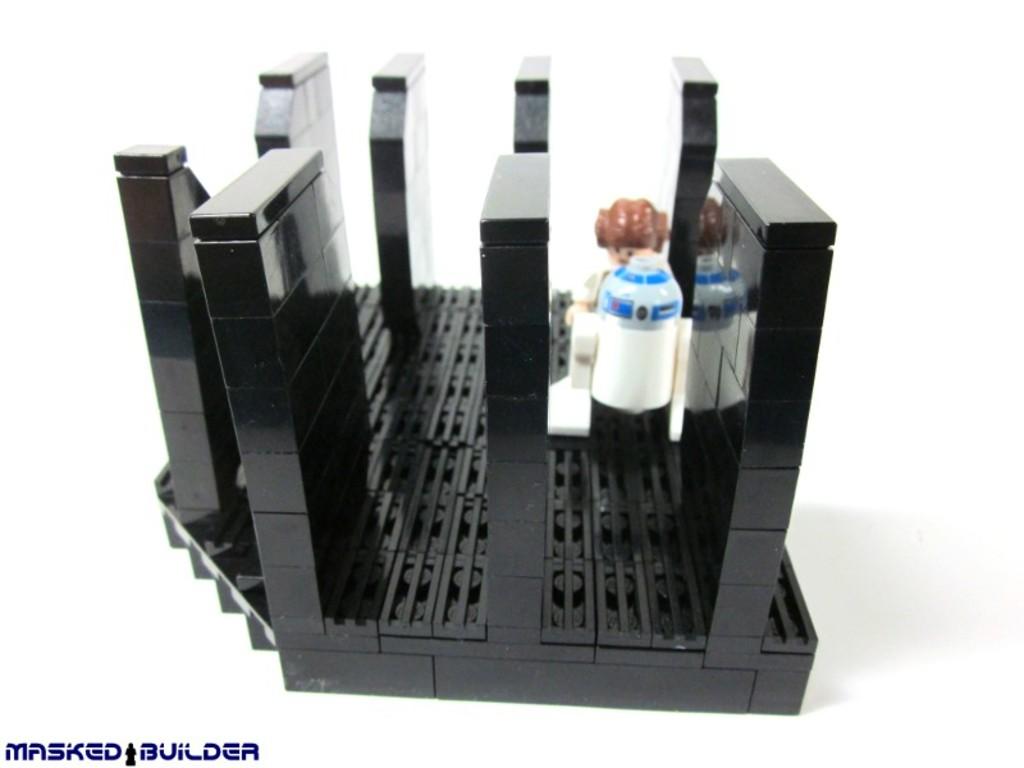Who made the toy?
Offer a terse response. Masked builder. What is the brand name of this toy?
Offer a very short reply. Masked builder. 